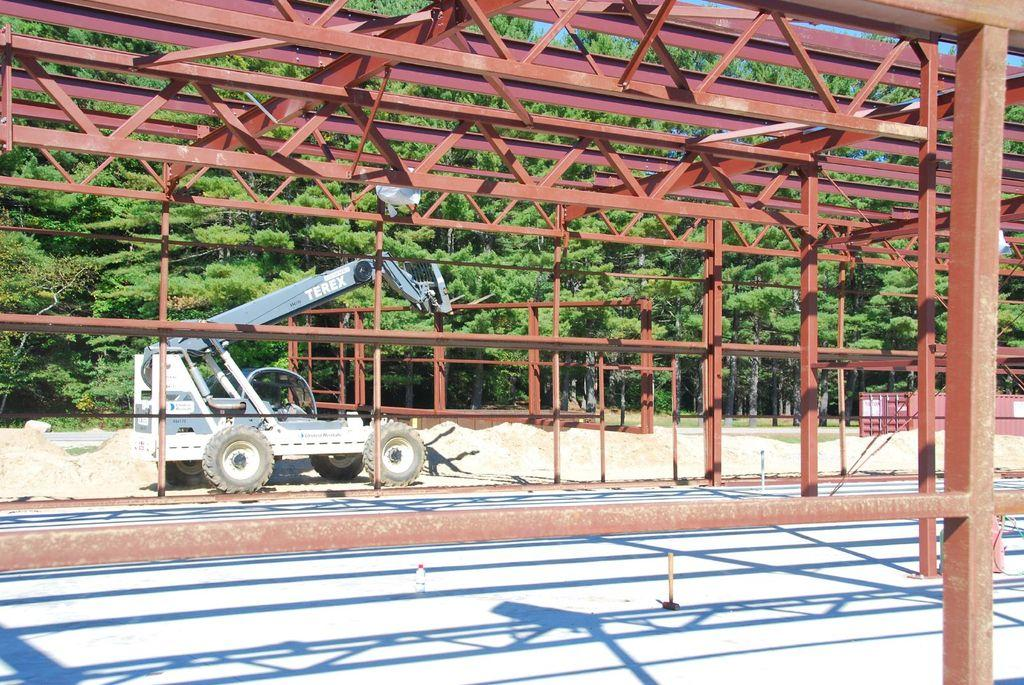What objects are present in the image that resemble long, thin bars? There are rods in the image. What type of transportation is visible in the image? There is a vehicle in the image. What type of barrier can be seen in the image? There is a fence in the image. What type of vegetation is present in the image? There are trees in the image. What type of fuel is being used by the owl in the image? There is no owl present in the image, so it is not possible to determine what type of fuel it might be using. 